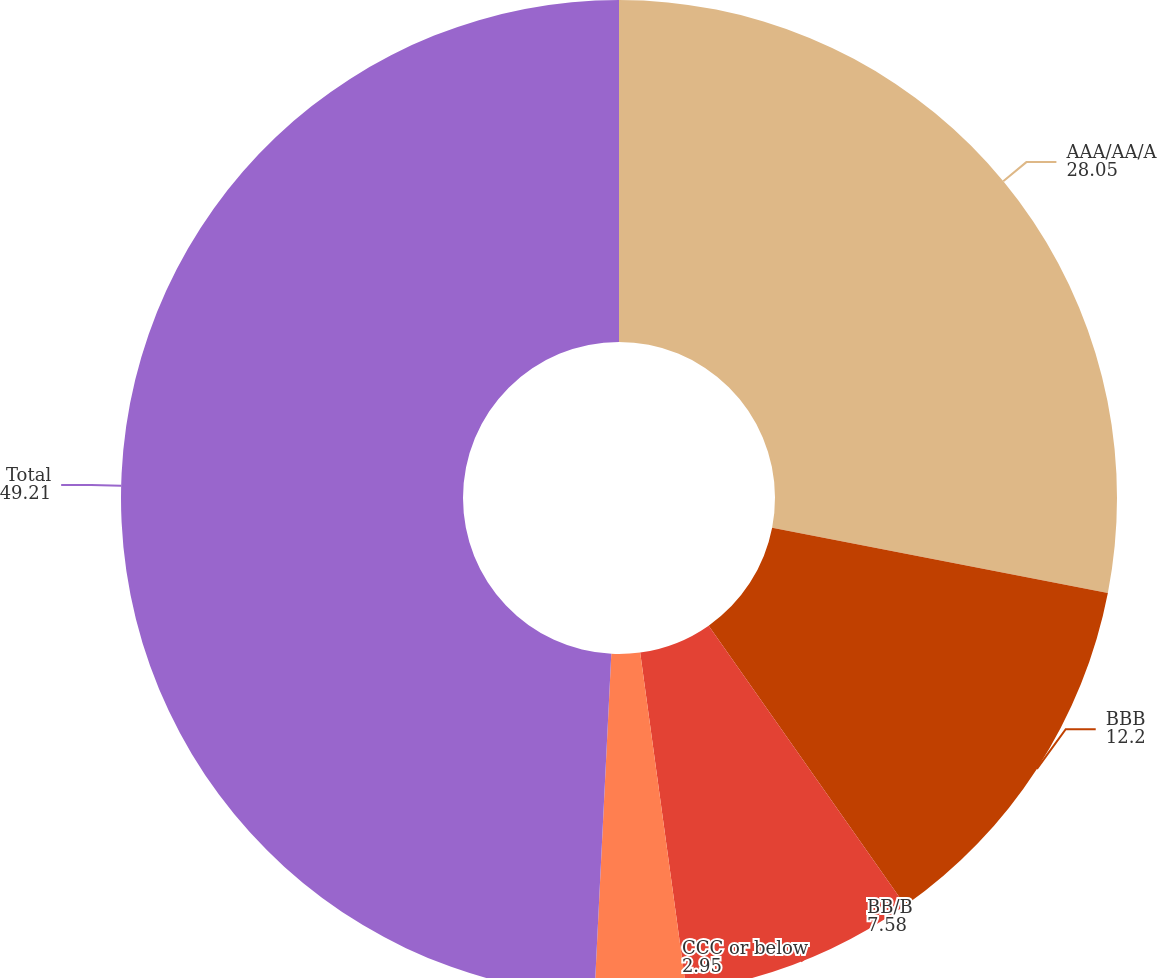Convert chart to OTSL. <chart><loc_0><loc_0><loc_500><loc_500><pie_chart><fcel>AAA/AA/A<fcel>BBB<fcel>BB/B<fcel>CCC or below<fcel>Total<nl><fcel>28.05%<fcel>12.2%<fcel>7.58%<fcel>2.95%<fcel>49.21%<nl></chart> 